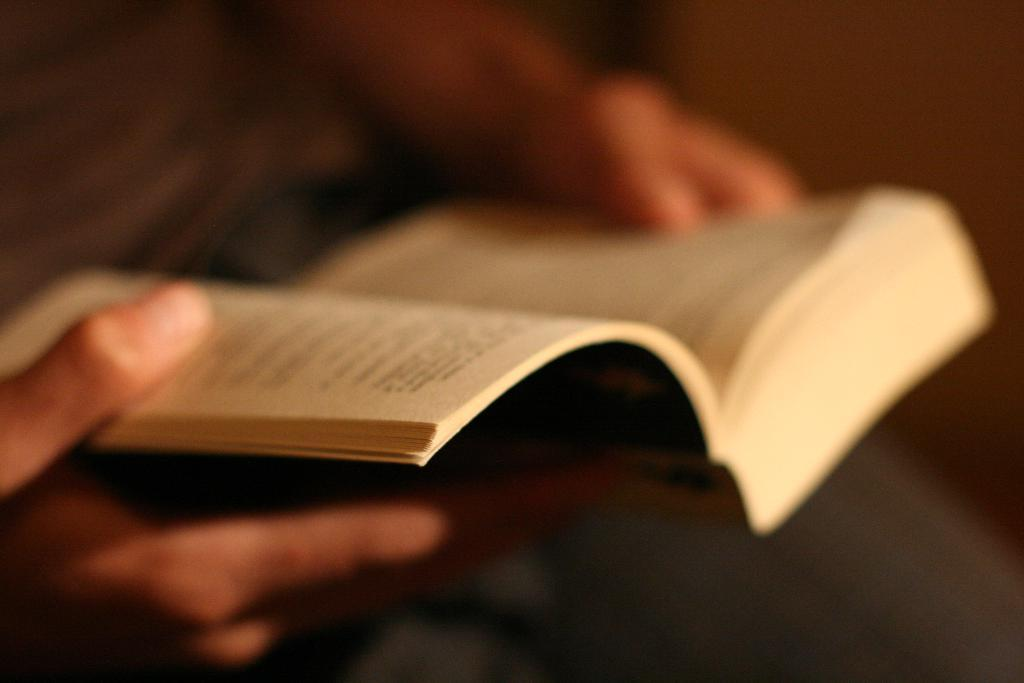What is the main subject of the image? There is a person in the image. What is the person holding in the image? The person is holding a book. What type of feast is being prepared on the tray in the image? There is no tray or feast present in the image; it only features a person holding a book. 